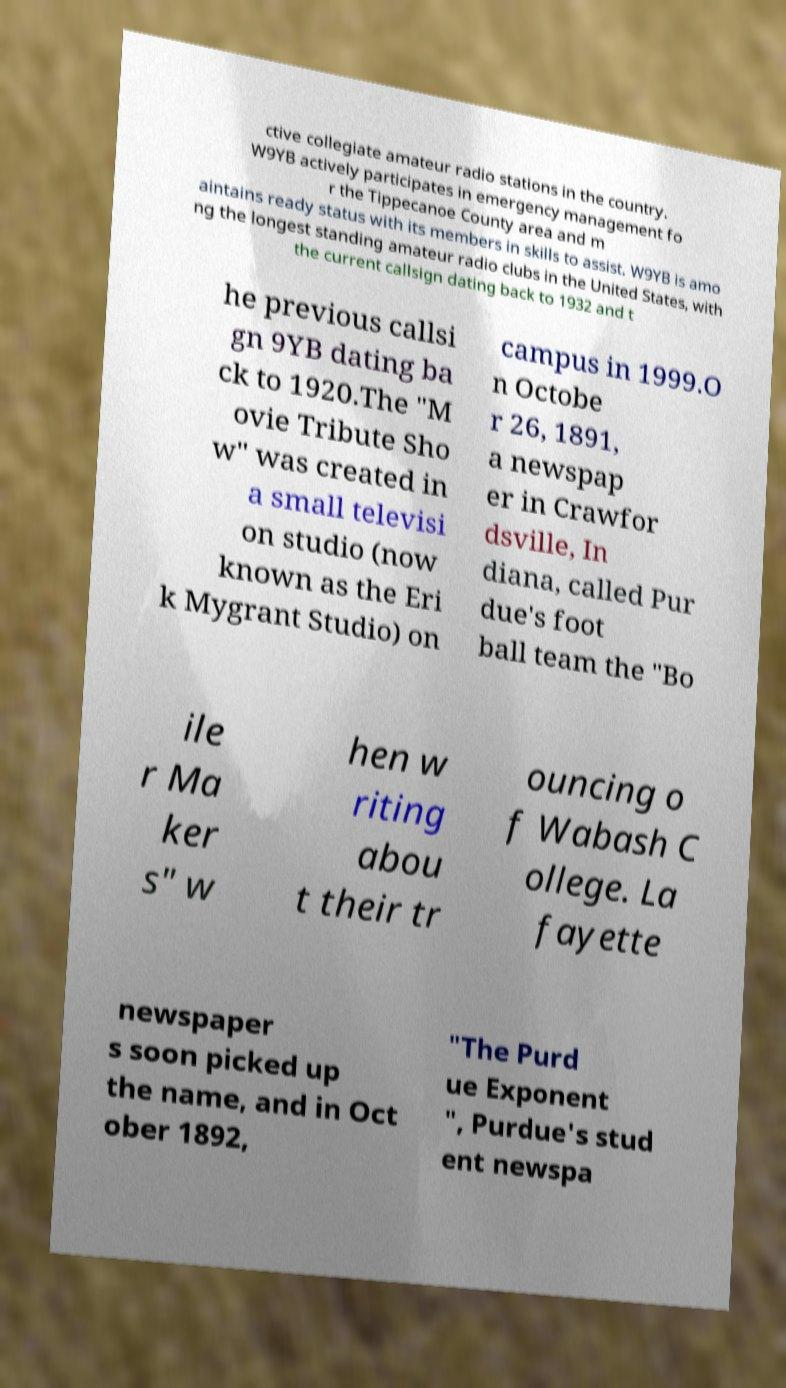Could you assist in decoding the text presented in this image and type it out clearly? ctive collegiate amateur radio stations in the country. W9YB actively participates in emergency management fo r the Tippecanoe County area and m aintains ready status with its members in skills to assist. W9YB is amo ng the longest standing amateur radio clubs in the United States, with the current callsign dating back to 1932 and t he previous callsi gn 9YB dating ba ck to 1920.The "M ovie Tribute Sho w" was created in a small televisi on studio (now known as the Eri k Mygrant Studio) on campus in 1999.O n Octobe r 26, 1891, a newspap er in Crawfor dsville, In diana, called Pur due's foot ball team the "Bo ile r Ma ker s" w hen w riting abou t their tr ouncing o f Wabash C ollege. La fayette newspaper s soon picked up the name, and in Oct ober 1892, "The Purd ue Exponent ", Purdue's stud ent newspa 